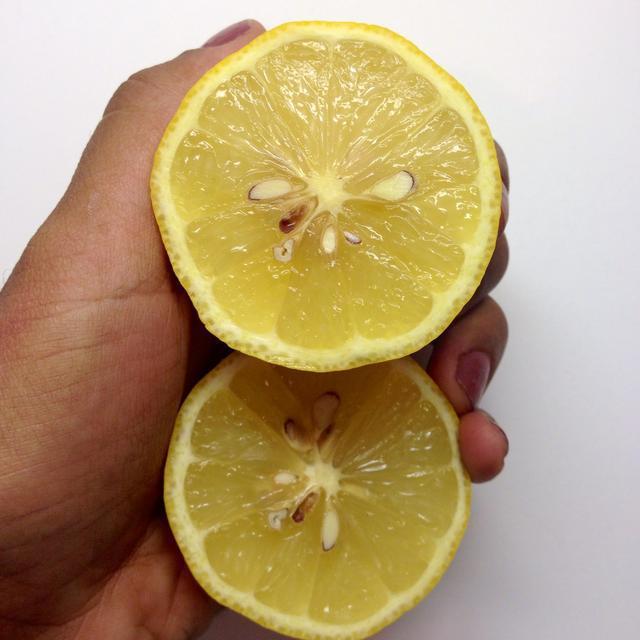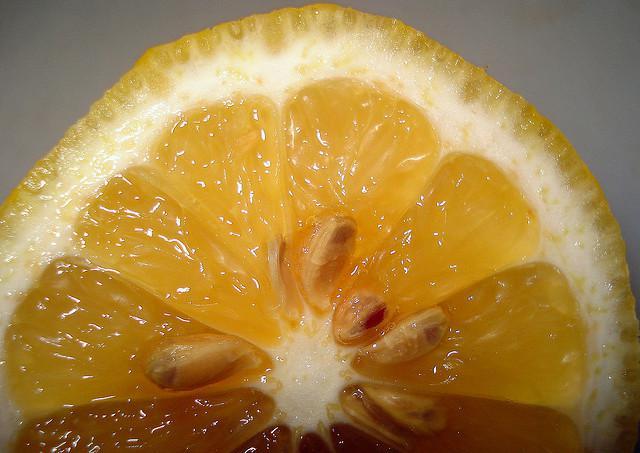The first image is the image on the left, the second image is the image on the right. For the images displayed, is the sentence "The left and right image contains a total of three lemons." factually correct? Answer yes or no. Yes. The first image is the image on the left, the second image is the image on the right. Given the left and right images, does the statement "An image includes a knife beside a lemon cut in half on a wooden cutting surface." hold true? Answer yes or no. No. 